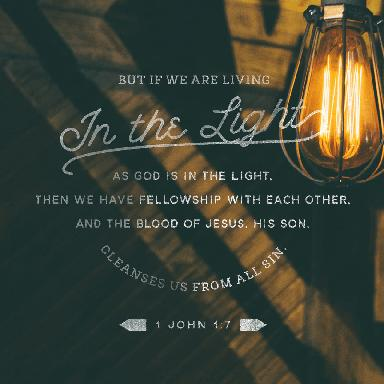What is the verse mentioned in the image? The image displays the verse 1 John 1:7, framed by a striking visual of a light bulb illuminating the surrounding darkness. This creates a powerful visual metaphor that complements the verse's message about living in God's light. 